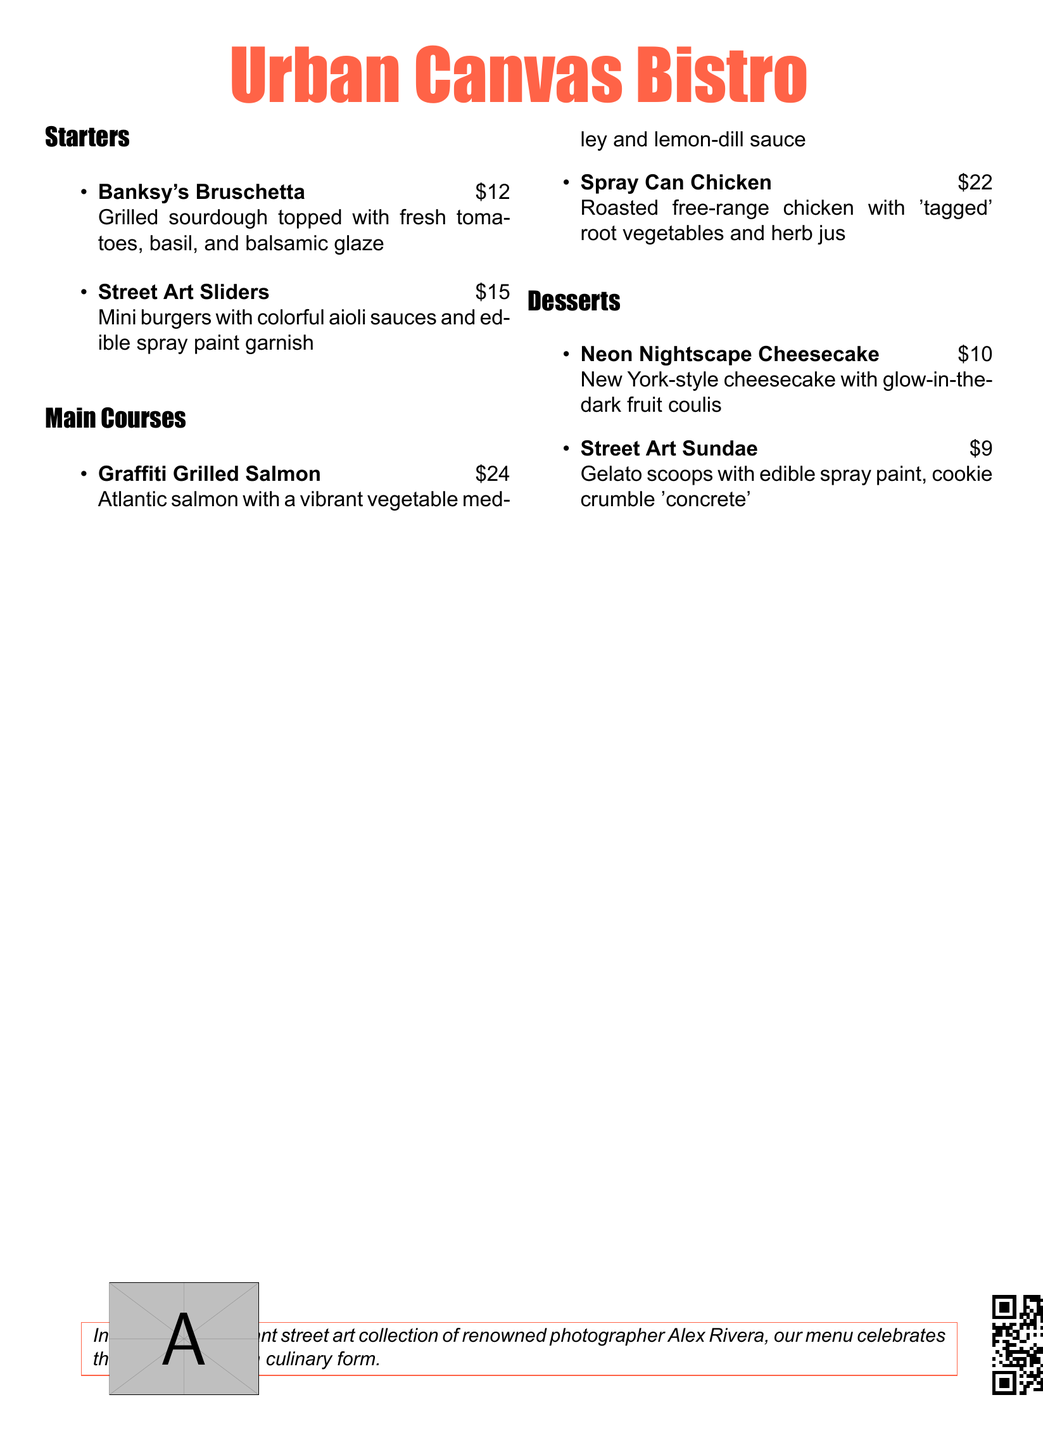What is the name of the bistro? The name of the bistro is prominently displayed at the top of the menu document.
Answer: Urban Canvas Bistro What is the price of the Street Art Sliders? The price is listed right next to the name of the dish under the Starters section.
Answer: $15 How many main courses are listed on the menu? The number of main courses can be found by counting the items listed under the Main Courses section.
Answer: 2 What topping is featured in Banksy's Bruschetta? The toppings are mentioned in the description of the dish under the Starters section.
Answer: Fresh tomatoes, basil, and balsamic glaze What is unique about the Neon Nightscape Cheesecake? This detail is included in the description of the dessert under the Desserts section.
Answer: Glow-in-the-dark fruit coulis Which dish includes a vegetable medley? The dish name is indicated in the Main Courses section and includes a description mentioning the ingredients.
Answer: Graffiti Grilled Salmon What color is used for the bistro name? The color used is specified in the formatting of the document and is highlighted at the top.
Answer: Spraypaint (RGB: 255,99,71) Who is the photographer inspiring the menu? The inspiration for the menu is mentioned at the bottom of the document.
Answer: Alex Rivera 